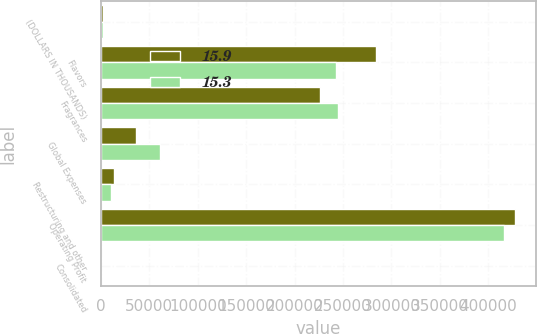<chart> <loc_0><loc_0><loc_500><loc_500><stacked_bar_chart><ecel><fcel>(DOLLARS IN THOUSANDS)<fcel>Flavors<fcel>Fragrances<fcel>Global Expenses<fcel>Restructuring and other<fcel>Operating Profit<fcel>Consolidated<nl><fcel>15.9<fcel>2011<fcel>284246<fcel>226560<fcel>36410<fcel>13172<fcel>427729<fcel>15.3<nl><fcel>15.3<fcel>2010<fcel>242528<fcel>244966<fcel>61056<fcel>10077<fcel>416361<fcel>15.9<nl></chart> 